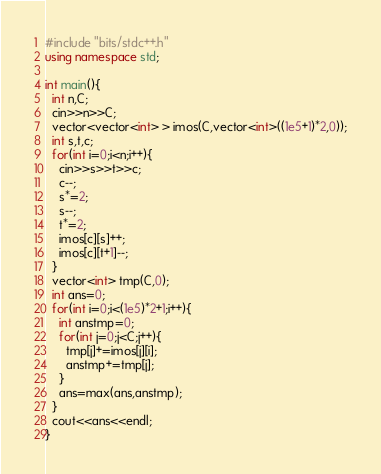Convert code to text. <code><loc_0><loc_0><loc_500><loc_500><_C++_>#include "bits/stdc++.h"
using namespace std;

int main(){
  int n,C;
  cin>>n>>C;
  vector<vector<int> > imos(C,vector<int>((1e5+1)*2,0));
  int s,t,c;
  for(int i=0;i<n;i++){
    cin>>s>>t>>c;
    c--;
    s*=2;
    s--;
    t*=2;
    imos[c][s]++;
    imos[c][t+1]--;
  }
  vector<int> tmp(C,0);
  int ans=0;
  for(int i=0;i<(1e5)*2+1;i++){
    int anstmp=0;
    for(int j=0;j<C;j++){
      tmp[j]+=imos[j][i];
      anstmp+=tmp[j];
    }
    ans=max(ans,anstmp);
  }
  cout<<ans<<endl;
}
</code> 